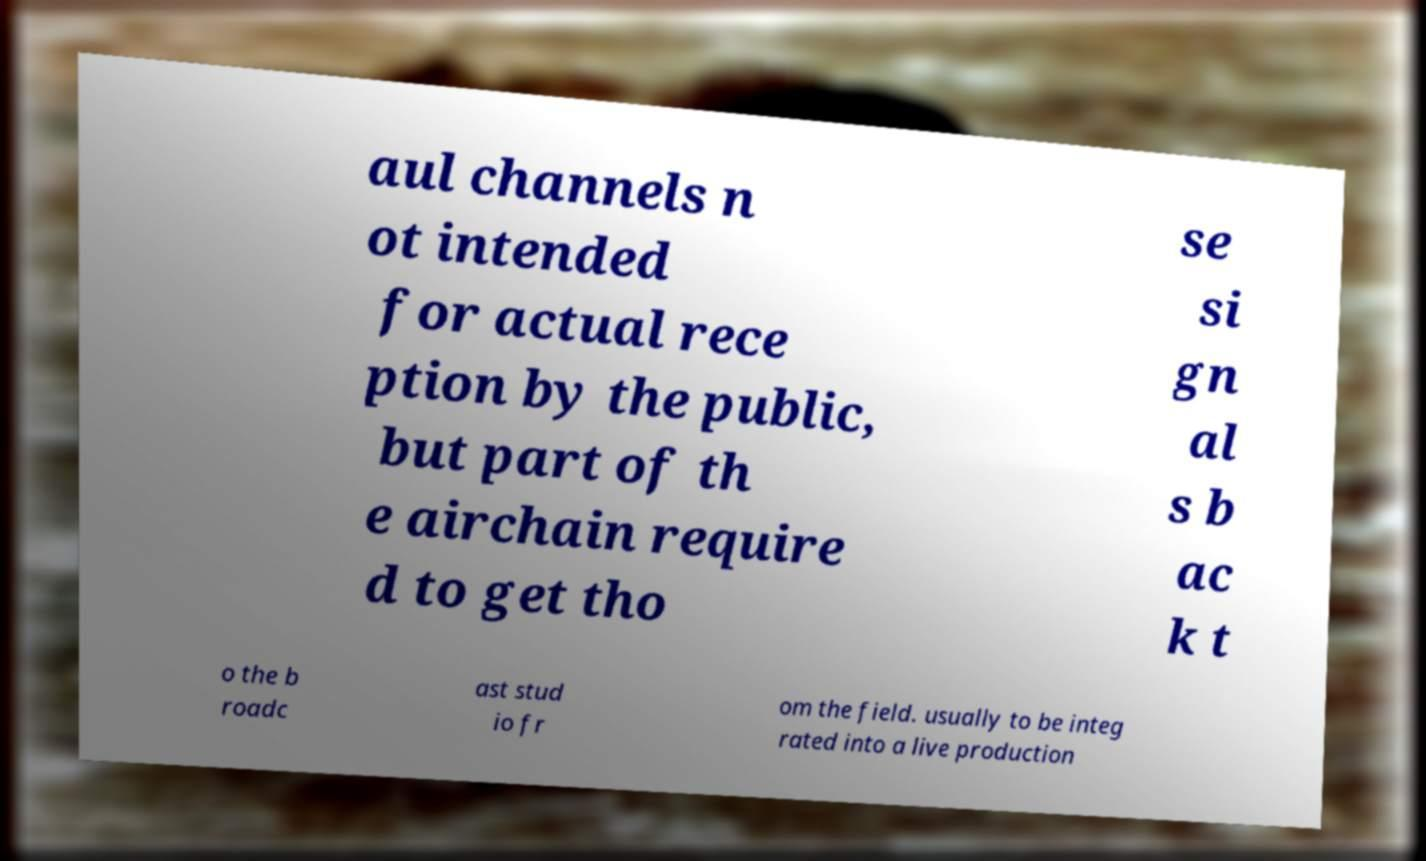Can you accurately transcribe the text from the provided image for me? aul channels n ot intended for actual rece ption by the public, but part of th e airchain require d to get tho se si gn al s b ac k t o the b roadc ast stud io fr om the field. usually to be integ rated into a live production 